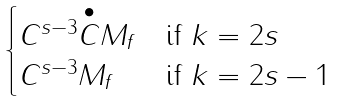<formula> <loc_0><loc_0><loc_500><loc_500>\begin{cases} C ^ { s - 3 } \overset { \bullet } { C } M _ { f } & \text {if $k=2s$} \\ C ^ { s - 3 } M _ { f } & \text {if $k=2s-1$} \end{cases}</formula> 